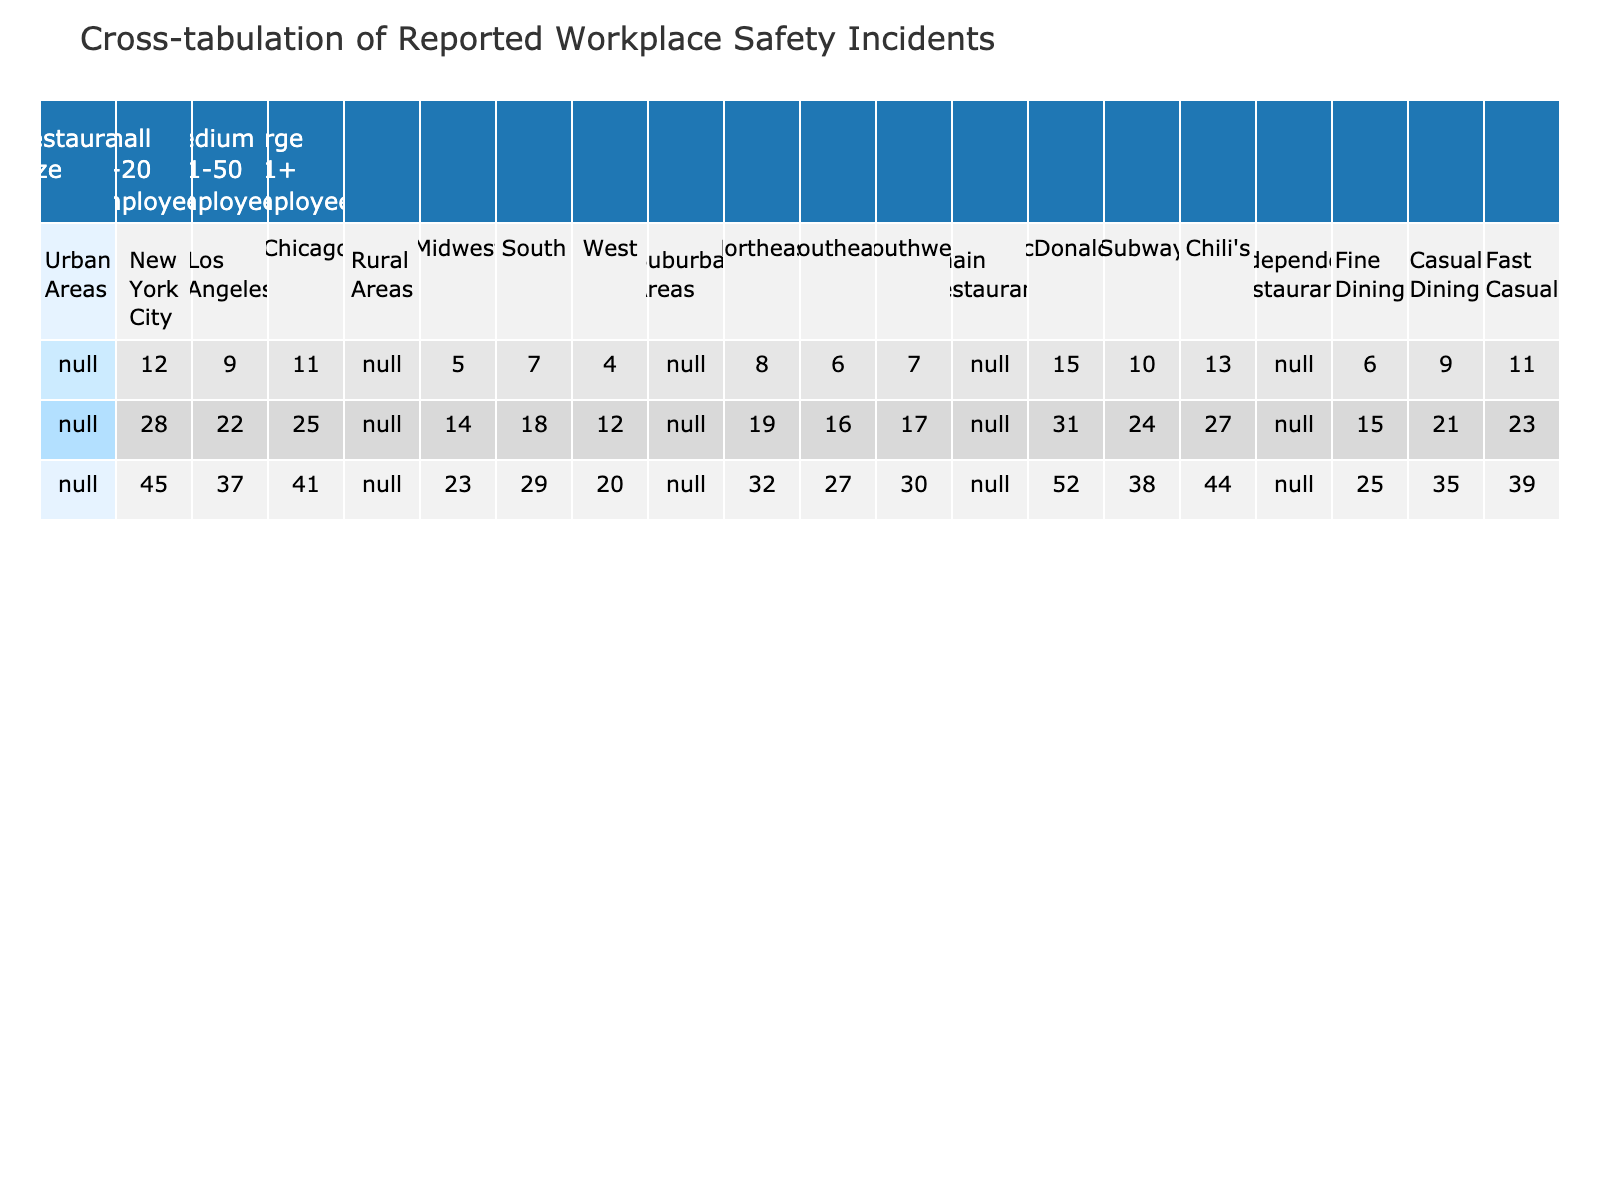What is the total number of reported safety incidents in New York City? From the table, adding the incidents across all restaurant sizes in New York City gives: 12 (Small) + 28 (Medium) + 45 (Large) = 85.
Answer: 85 Which size of restaurant reported the highest number of incidents in Los Angeles? In Los Angeles, the counts are: 9 (Small), 22 (Medium), and 37 (Large). The largest number, 37, is from Large restaurants.
Answer: Large What is the difference in reported safety incidents between Medium-sized restaurants in Urban and Rural areas? For Medium-sized restaurants, Urban areas have 28 (NYC) + 22 (Los Angeles) + 25 (Chicago) = 75 incidents. Rural areas have 14 (Midwest) + 18 (South) + 12 (West) = 44. The difference is 75 - 44 = 31.
Answer: 31 Are there more reported safety incidents in Fine Dining or Casual Dining? Fine Dining has 25 incidents and Casual Dining has 35 incidents. Since 35 is greater than 25, there are more incidents in Casual Dining.
Answer: Yes What is the average number of reported safety incidents for Large restaurants in Urban areas? For Large restaurants in Urban areas, we sum the incidents: 45 (NYC) + 37 (Los Angeles) + 41 (Chicago) = 123. There are 3 data points, so the average is 123 / 3 = 41.
Answer: 41 How does the total number of reported incidents for Independent restaurants compare to Chain restaurants? Summing Independent restaurants: 25 (Fine Dining) + 35 (Casual Dining) + 39 (Fast Casual) = 99 incidents. Chain restaurants: 52 (McDonald's) + 38 (Subway) + 44 (Chili's) = 134 incidents. Thus, Chain restaurants have more with 134 - 99 = 35 more incidents.
Answer: Chain restaurants have more What percentage of reported incidents in the South come from Large restaurants? In the South, incidents are: 29 (Large) + 18 (Medium) + 7 (Small) = 54 total. The percentage of Large restaurant incidents is (29 / 54) * 100 ≈ 53.7%.
Answer: 53.7% Which location has the highest number of reported incidents among all restaurant sizes? Comparing totals from each location: NYC (85), Los Angeles (68), Chicago (77), Midwest (42), South (54), West (36), Northeast (59), Southeast (49), Southwest (54), McDonald's (52), Subway (38), Chili's (44), Fine Dining (25), Casual Dining (35), Fast Casual (39). NYC has the highest at 85.
Answer: New York City If we look at Small restaurants combined from all locations, what is the total number of incidents reported? Summing incidents from all locations for Small restaurants: 12 (NYC) + 9 (Los Angeles) + 11 (Chicago) + 5 (Midwest) + 7 (South) + 4 (West) + 8 (Northeast) + 6 (Southeast) + 7 (Southwest) + 15 (McDonald's) + 10 (Subway) + 13 (Chili's) + 6 (Fine Dining) + 9 (Casual Dining) + 11 (Fast Casual). The total is 12 + 9 + 11 + 5 + 7 + 4 + 8 + 6 + 7 + 15 + 10 + 13 + 6 + 9 + 11 =  15 + 10 + 13 + 6 + 9 + 11 = 121.
Answer: 121 What is the total number of safety incidents reported in the Northeast Suburban area? In the Northeast suburban area, the incidents are: 8 (Small) + 19 (Medium) + 32 (Large) = 59 total.
Answer: 59 